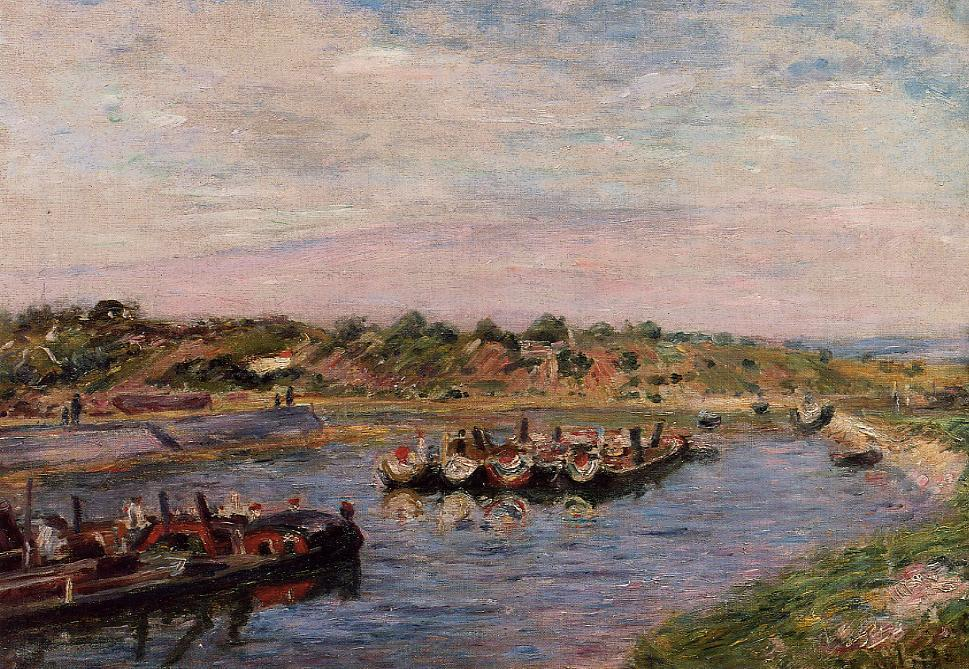Can you elaborate on the elements of the picture provided? The image illustrates an exquisite impressionist painting depicting a lively river scene. The artist employs a loose, sketchy style, characterized by visible brushstrokes that impart a strong sense of movement and vibrancy to the composition. 

The scene features a river that serves as the central element, animated by boats adorned with flags and banners, accentuating a festive atmosphere. The color palette is dominated by soft pastel hues, with pinks, blues, and greens blending seamlessly to evoke a serene and tranquil ambiance. 

Along the riverbanks, people are seen, their bright garments and hats adding further splashes of color and energy to the painting. These figures seem to be enjoying a leisurely day, potentially participating in a local festival or celebration. 

In the background, a hill dotted with trees and houses adds depth and perspective, enhancing the painting’s realism. Above, the sky unfolds in a clear blue expanse, punctuated by scattered white clouds, further contributing to the picturesque quality of the scene. 

Overall, the painting stands as a splendid example of the impressionist genre, capturing fleeting effects of light and color in the natural world, while invoking a sense of joy and festivity. 